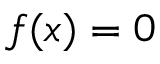<formula> <loc_0><loc_0><loc_500><loc_500>f ( x ) = 0</formula> 